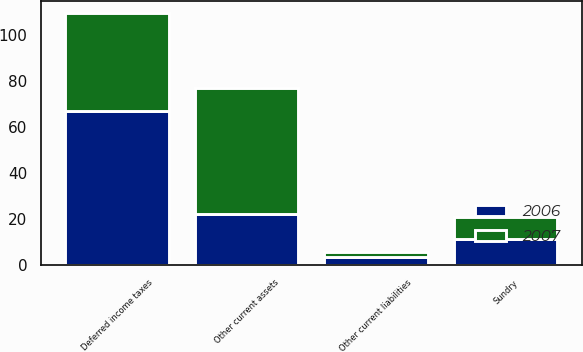<chart> <loc_0><loc_0><loc_500><loc_500><stacked_bar_chart><ecel><fcel>Other current assets<fcel>Sundry<fcel>Other current liabilities<fcel>Deferred income taxes<nl><fcel>2007<fcel>55.1<fcel>9.4<fcel>1.8<fcel>42.3<nl><fcel>2006<fcel>22<fcel>11.3<fcel>3.7<fcel>67.1<nl></chart> 